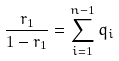Convert formula to latex. <formula><loc_0><loc_0><loc_500><loc_500>\frac { r _ { 1 } } { 1 - r _ { 1 } } = \sum _ { i = 1 } ^ { n - 1 } q _ { i }</formula> 